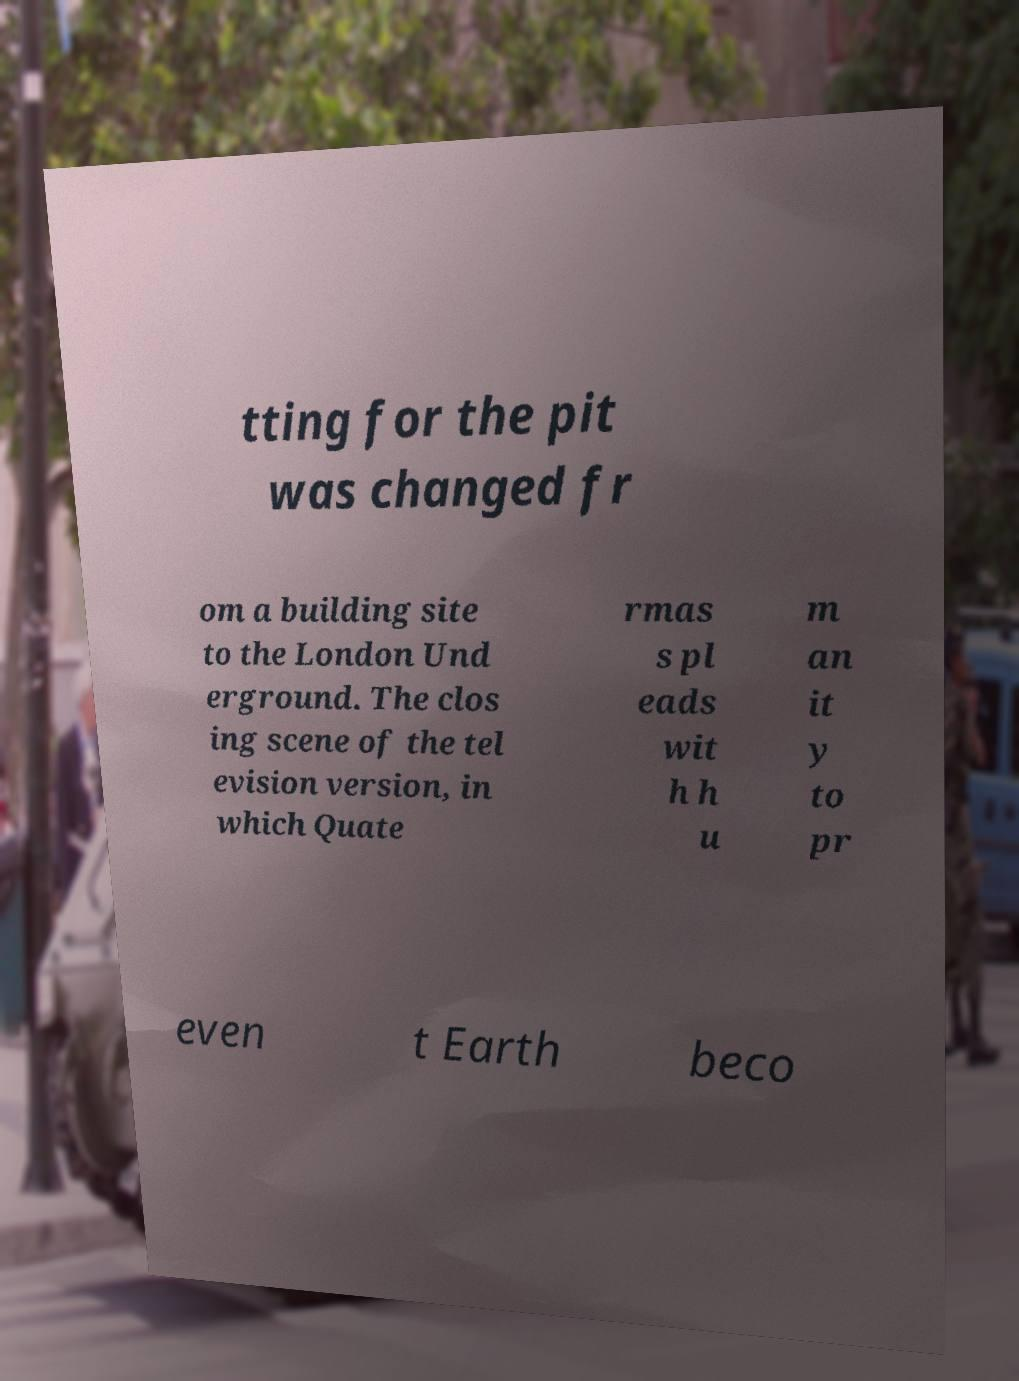There's text embedded in this image that I need extracted. Can you transcribe it verbatim? tting for the pit was changed fr om a building site to the London Und erground. The clos ing scene of the tel evision version, in which Quate rmas s pl eads wit h h u m an it y to pr even t Earth beco 